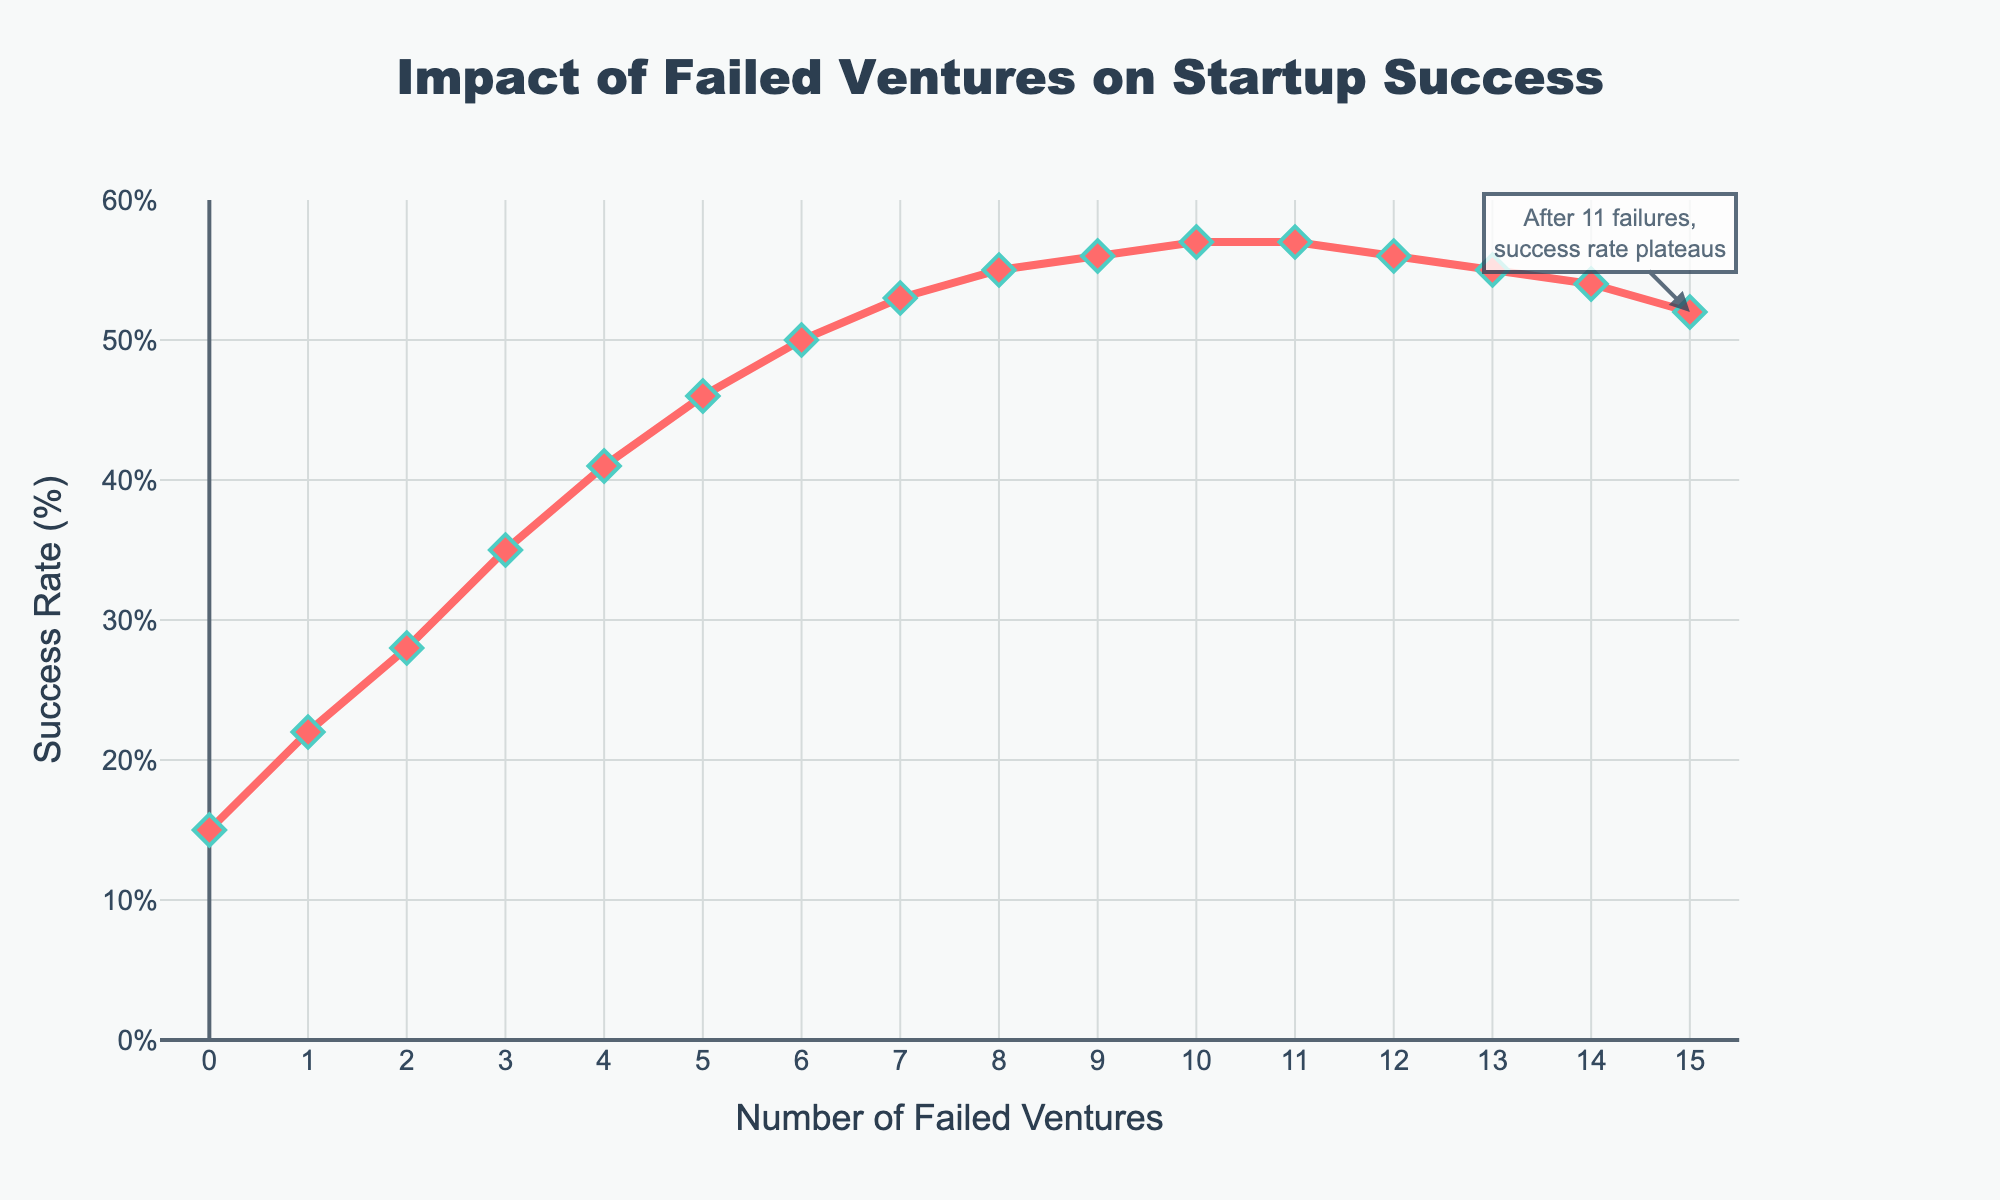What is the success rate when there is 0 failed ventures? The success rate for 0 failed ventures is directly shown as the first data point on the x-axis.
Answer: 15% What is the trend of the success rate with increasing number of failed ventures up to 10 failures? The success rate increases with an increasing number of failed ventures up to 10 failures. It starts at 15%, reaches a peak of 57% at 10 failures, demonstrating a positive correlation.
Answer: Increases At which number of failed ventures does the success rate plateau? The annotation in the chart indicates that after 11 failures, the success rate plateaus. This can also be seen as the success rate flattens out after reaching 57% at 11 failed ventures.
Answer: 11 How many failed ventures correlate with a 50% success rate? Looking at the graph, the success rate reaches 50% at the 6 failed ventures mark. This can also be seen from the exact data points listed.
Answer: 6 Is the success rate higher at 3 failed ventures or at 13 failed ventures? Comparing the y-values for 3 failed ventures (35%) and 13 failed ventures (55%), it is higher at 3 failed ventures.
Answer: 35% Between which failed ventures does the success rate experience the largest increase? The largest increase in success rate occurs between the 3rd (35%) and 4th (41%) failed ventures, indicating a 6 percentage point increase.
Answer: Between 3 and 4 What is the difference in success rate between 4 and 8 failed ventures? The success rate at 4 failed ventures is 41% and at 8 failed ventures is 55%. The difference is 55% - 41% = 14%.
Answer: 14% From the visual attributes, what color represents the success rate line? The success rate line in the chart is visually represented by a red line.
Answer: Red At what point does the success rate begin to decline after initially increasing? The success rate begins to decline after peaking at 10 failed ventures (57%) starting from 12 failed ventures (56%).
Answer: After 12 Which points on the x-axis have the same success rate? The points at 10 and 11 failed ventures both have a success rate of 57%.
Answer: 10 and 11 